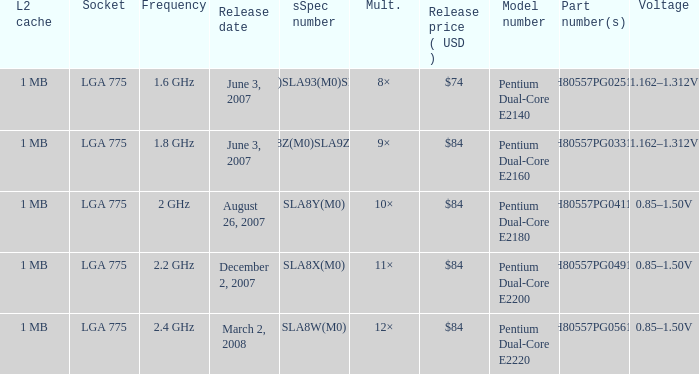What part number(s) has a frequency of 2.4 ghz? HH80557PG0561M. 